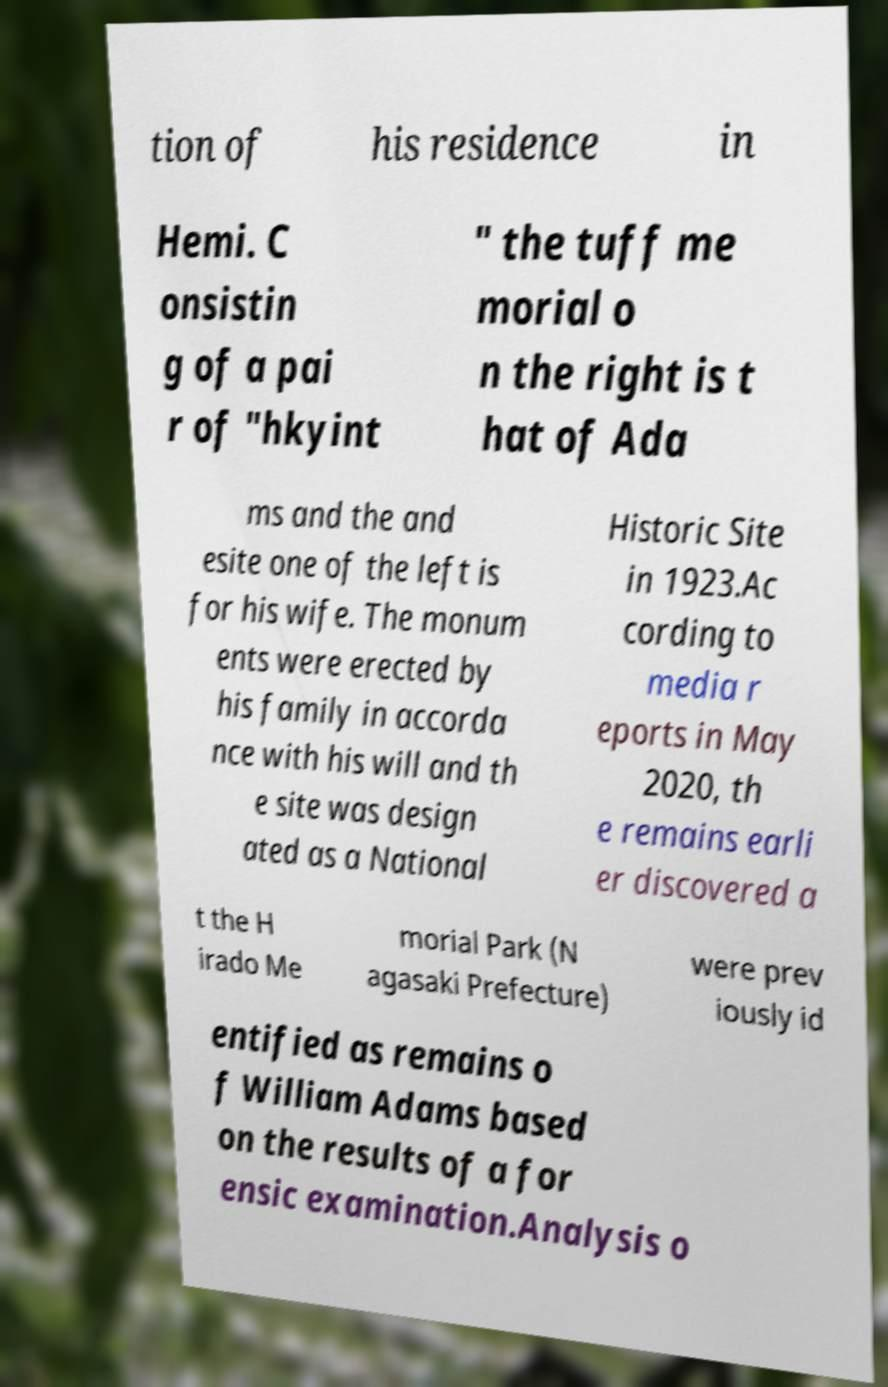Could you extract and type out the text from this image? tion of his residence in Hemi. C onsistin g of a pai r of "hkyint " the tuff me morial o n the right is t hat of Ada ms and the and esite one of the left is for his wife. The monum ents were erected by his family in accorda nce with his will and th e site was design ated as a National Historic Site in 1923.Ac cording to media r eports in May 2020, th e remains earli er discovered a t the H irado Me morial Park (N agasaki Prefecture) were prev iously id entified as remains o f William Adams based on the results of a for ensic examination.Analysis o 